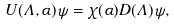<formula> <loc_0><loc_0><loc_500><loc_500>U ( \Lambda , \alpha ) \psi = \chi ( \alpha ) D ( \Lambda ) \psi ,</formula> 